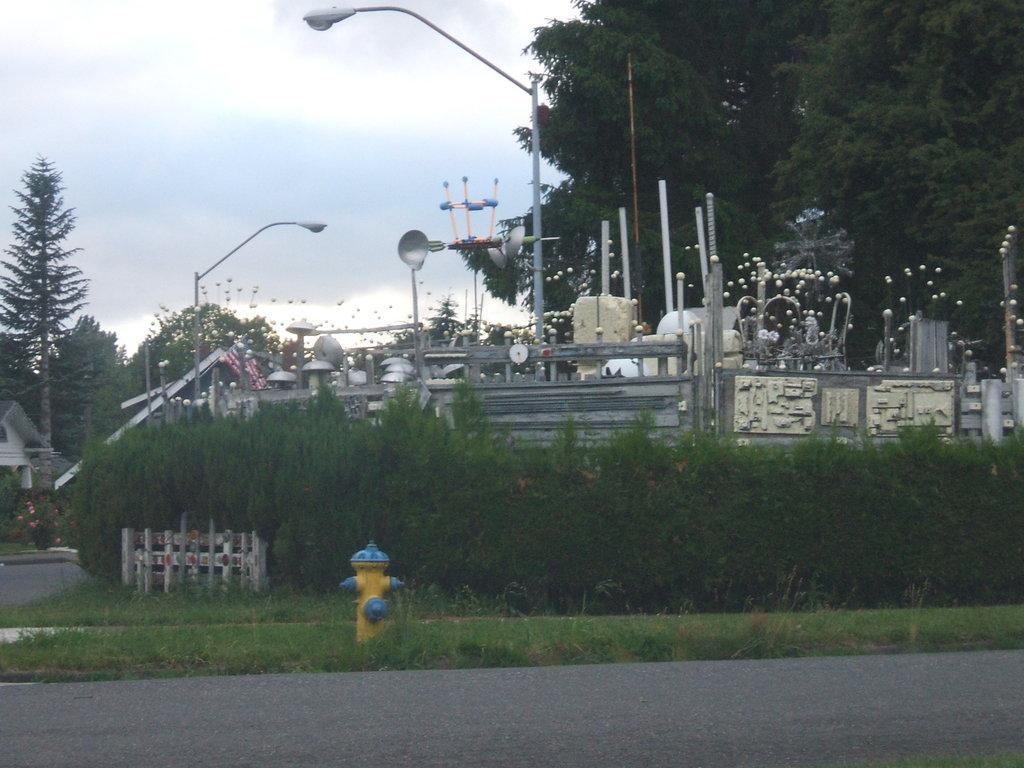How would you summarize this image in a sentence or two? In this image we can see grassy land, fire hydrant, fence, plants, trees, street light, poles, flag and some grey color thing. There is a road at the bottom of the image. We can see a house on the left side of the image. The sky is covered with clouds at the top of the image. 